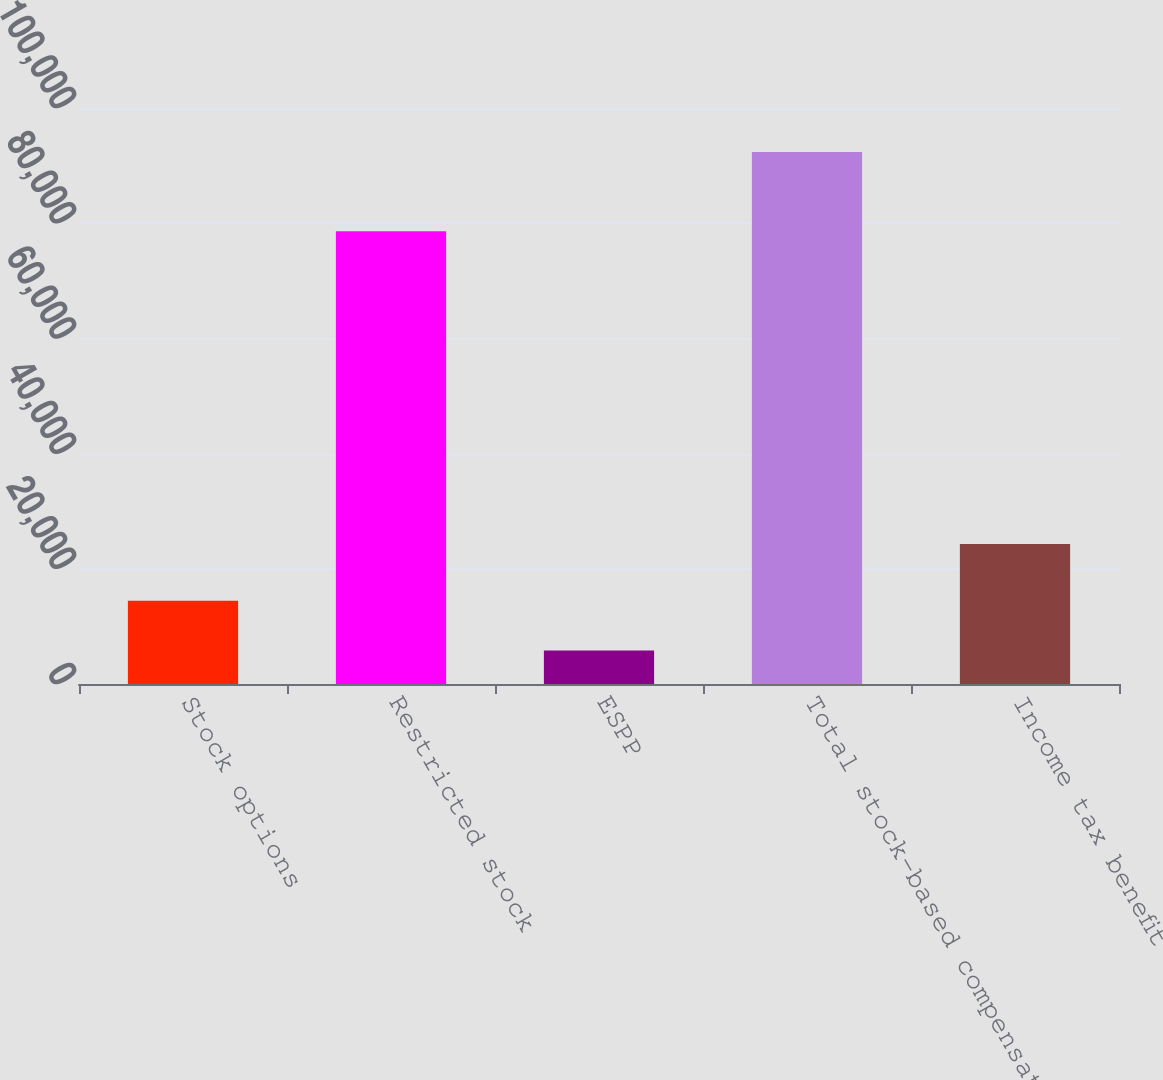Convert chart to OTSL. <chart><loc_0><loc_0><loc_500><loc_500><bar_chart><fcel>Stock options<fcel>Restricted stock<fcel>ESPP<fcel>Total stock-based compensation<fcel>Income tax benefit<nl><fcel>14474.8<fcel>78615<fcel>5823<fcel>92341<fcel>24294<nl></chart> 